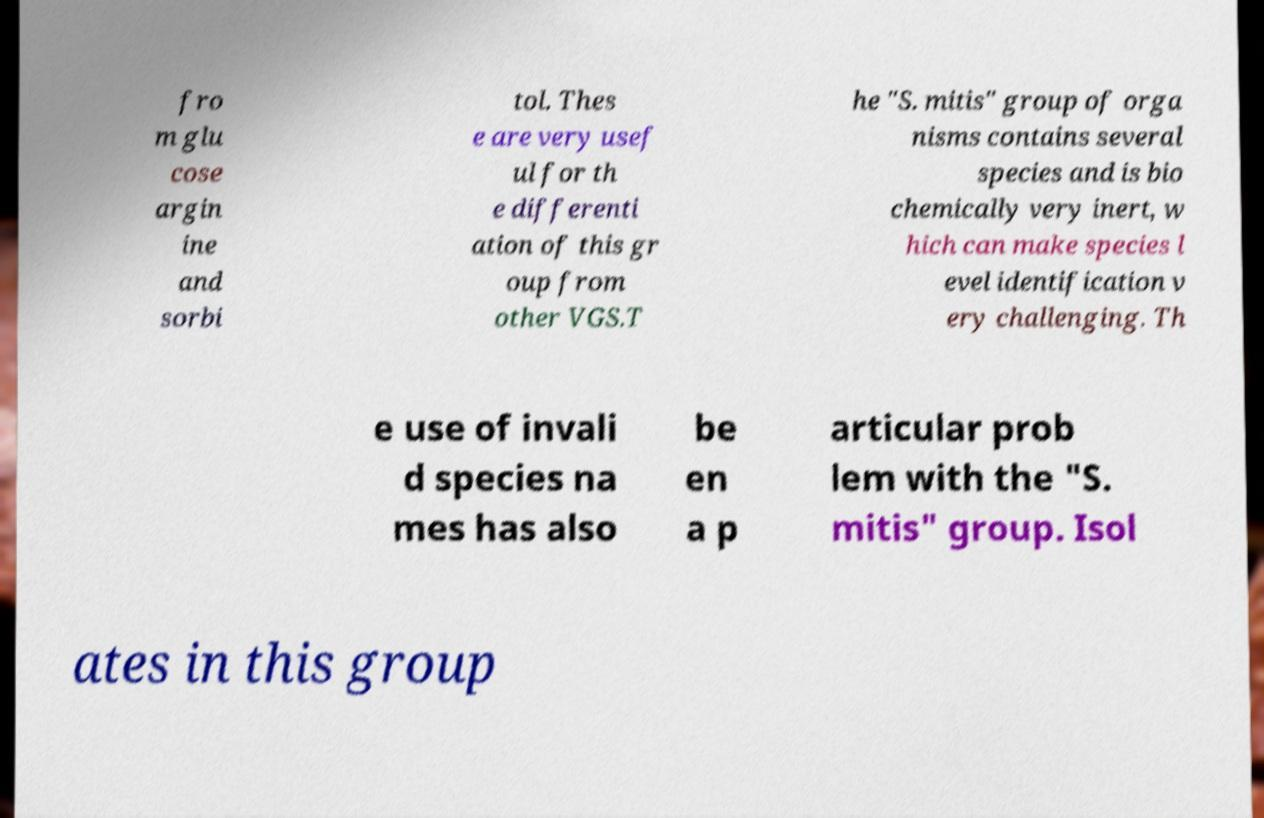Please identify and transcribe the text found in this image. fro m glu cose argin ine and sorbi tol. Thes e are very usef ul for th e differenti ation of this gr oup from other VGS.T he "S. mitis" group of orga nisms contains several species and is bio chemically very inert, w hich can make species l evel identification v ery challenging. Th e use of invali d species na mes has also be en a p articular prob lem with the "S. mitis" group. Isol ates in this group 